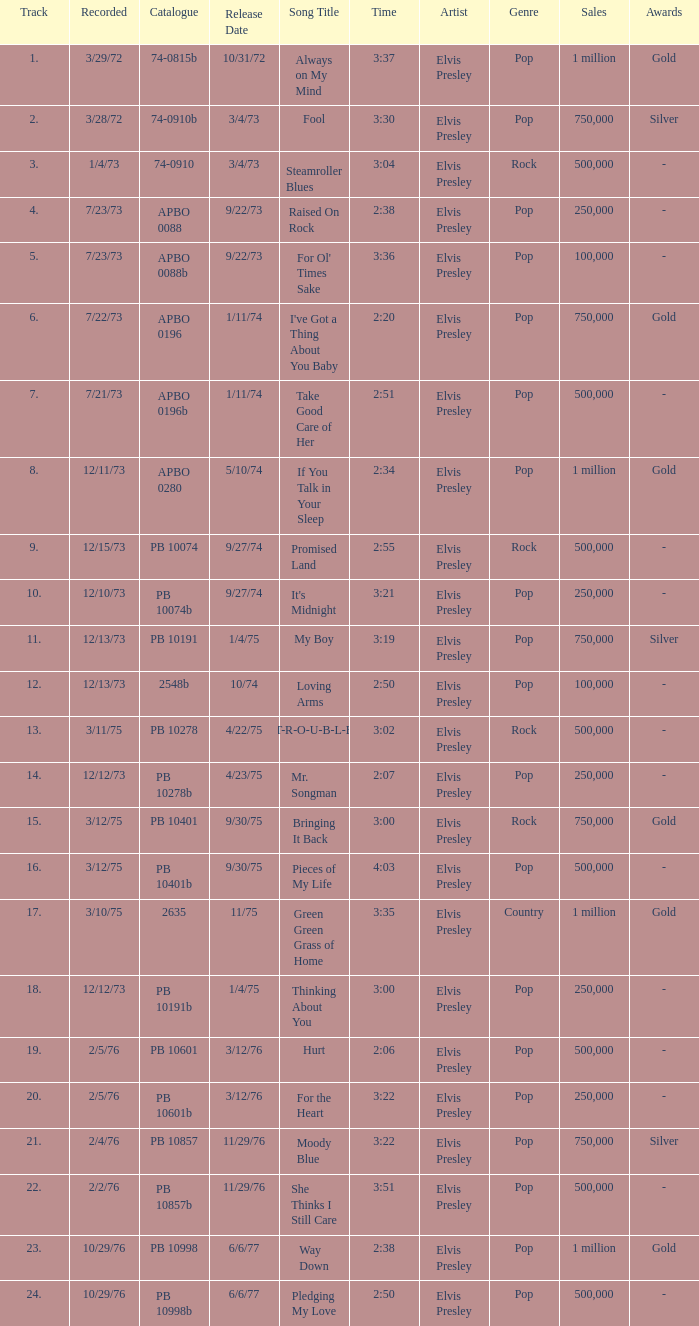Tell me the release date record on 10/29/76 and a time on 2:50 6/6/77. 